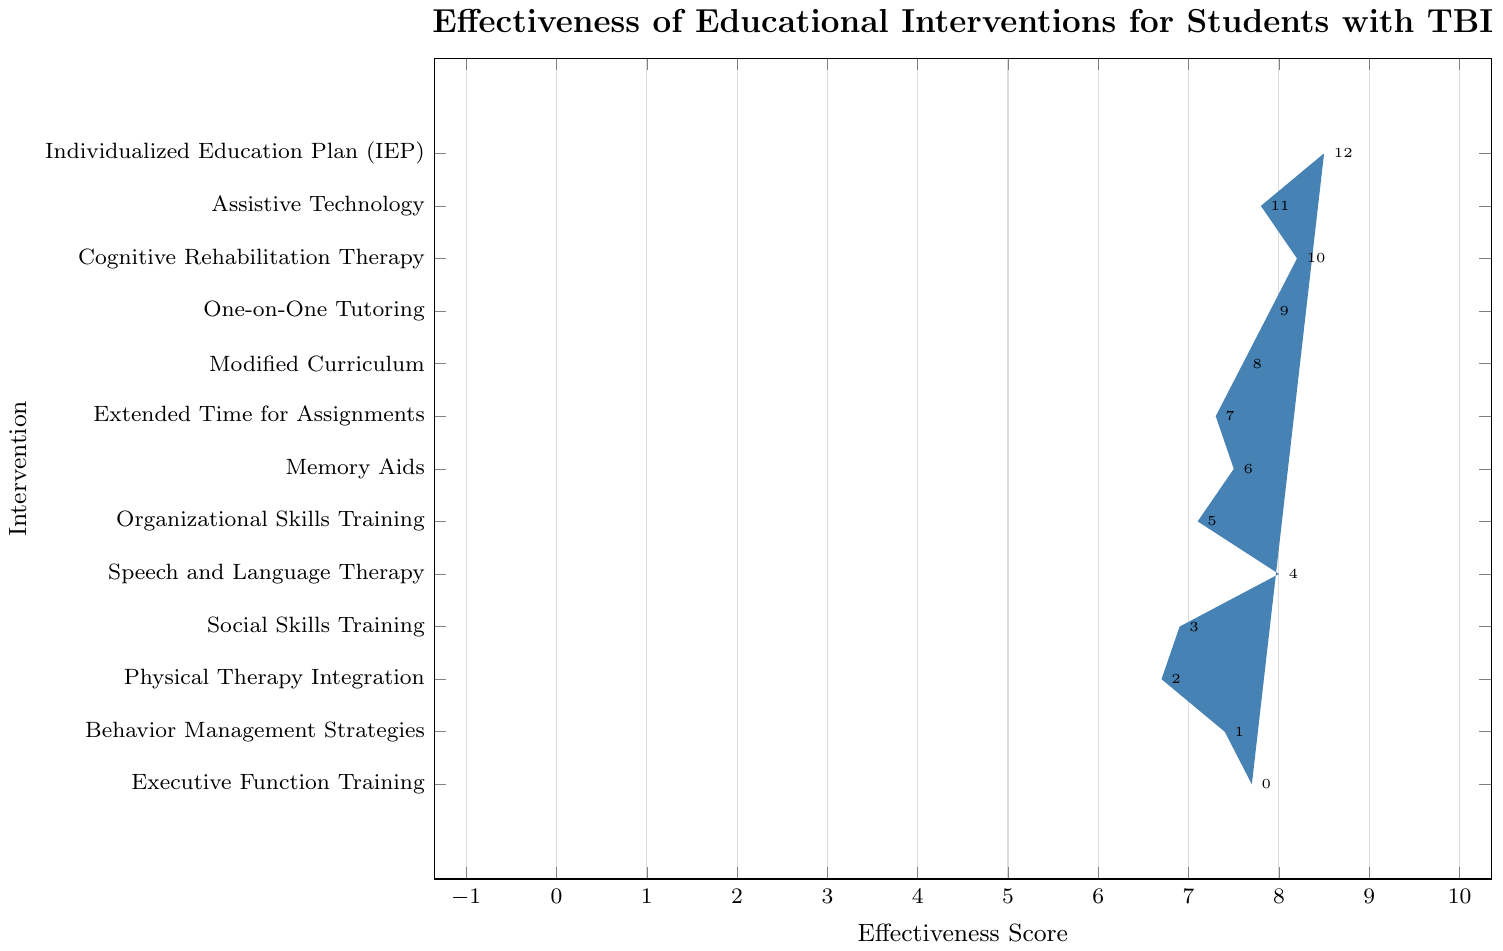Which intervention has the highest effectiveness score? The bar for the Individualized Education Plan (IEP) is the tallest among all, indicating it has the highest score.
Answer: Individualized Education Plan (IEP) Which intervention shows the least effectiveness? The bar for Physical Therapy Integration is the shortest among all, indicating it has the lowest score.
Answer: Physical Therapy Integration How many interventions have an effectiveness score higher than 8? Observing the bars, three interventions (Individualized Education Plan (IEP), Cognitive Rehabilitation Therapy, and Speech and Language Therapy) have scores higher than 8.
Answer: 3 What is the difference between the highest and the lowest effectiveness scores? The highest score is 8.5 (IEP) and the lowest is 6.7 (Physical Therapy Integration). The difference is 8.5 - 6.7 = 1.8.
Answer: 1.8 Which intervention is slightly more effective, Executive Function Training or Assistive Technology? Comparing the bars, Executive Function Training has an effectiveness score of 7.7 while Assistive Technology has a score of 7.8. Assistive Technology is slightly more effective.
Answer: Assistive Technology Arrange the interventions with scores above 8 in descending order. The bars indicating scores above 8 are ordered as follows: Individualized Education Plan (8.5), Cognitive Rehabilitation Therapy (8.2), and Speech and Language Therapy (8.0).
Answer: Individualized Education Plan, Cognitive Rehabilitation Therapy, Speech and Language Therapy Is there more than 1 point difference between the effectiveness scores of Frequent Breaks and Individualized Education Plan? Frequent Breaks has a score of 6.8, and Individualized Education Plan has a score of 8.5. The difference is 8.5 - 6.8 = 1.7, which is more than 1.
Answer: Yes Which intervention is more effective, Organizational Skills Training or One-on-One Tutoring? The bar for Organizational Skills Training shows a score of 7.1, while One-on-One Tutoring has a score of 7.9. One-on-One Tutoring is more effective.
Answer: One-on-One Tutoring What is the average effectiveness score of the interventions shown? Summing all effectiveness scores: 8.5 + 7.8 + 8.2 + 7.9 + 7.6 + 7.3 + 6.8 + 7.5 + 7.1 + 8.0 + 6.9 + 6.7 + 7.4 + 7.7 + 7.2 = 113.6. There are 15 interventions, so the average is 113.6 / 15 ≈ 7.57.
Answer: 7.57 